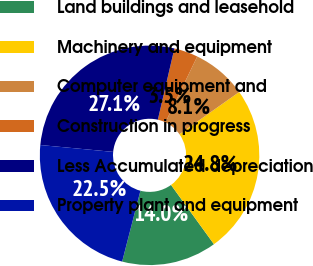Convert chart to OTSL. <chart><loc_0><loc_0><loc_500><loc_500><pie_chart><fcel>Land buildings and leasehold<fcel>Machinery and equipment<fcel>Computer equipment and<fcel>Construction in progress<fcel>Less Accumulated depreciation<fcel>Property plant and equipment<nl><fcel>14.0%<fcel>24.81%<fcel>8.06%<fcel>3.52%<fcel>27.14%<fcel>22.48%<nl></chart> 